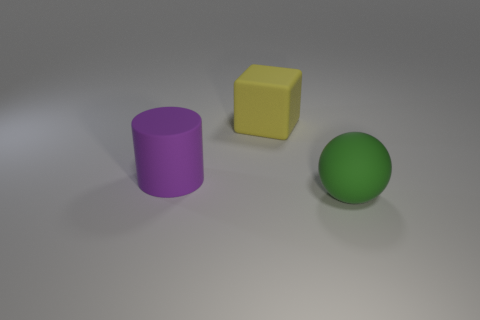How many large matte things are to the right of the block and behind the green ball?
Offer a very short reply. 0. How many balls are the same material as the big yellow block?
Provide a short and direct response. 1. Are there fewer big purple objects that are behind the large yellow matte block than spheres?
Ensure brevity in your answer.  Yes. What number of green matte balls are there?
Provide a succinct answer. 1. Do the green rubber thing and the big purple matte object have the same shape?
Give a very brief answer. No. There is a matte object to the right of the rubber thing that is behind the big cylinder; what size is it?
Provide a succinct answer. Large. Are there any other yellow things of the same size as the yellow rubber thing?
Keep it short and to the point. No. There is a block that is behind the large purple matte cylinder; does it have the same size as the green ball that is in front of the large purple matte thing?
Your answer should be compact. Yes. There is a thing that is in front of the rubber thing to the left of the yellow cube; what is its shape?
Your answer should be compact. Sphere. How many yellow rubber cubes are behind the big yellow block?
Your answer should be compact. 0. 